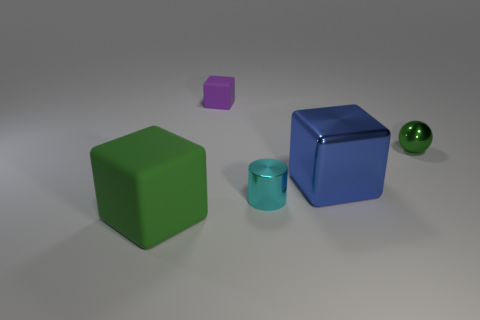What is the size of the block that is the same color as the small shiny ball?
Provide a short and direct response. Large. How many objects are purple rubber blocks that are behind the large blue shiny thing or tiny things in front of the purple thing?
Your answer should be compact. 3. There is a small shiny object that is the same color as the large matte cube; what is its shape?
Offer a very short reply. Sphere. What shape is the green thing on the left side of the tiny purple matte object?
Your answer should be very brief. Cube. Does the small thing on the left side of the cyan cylinder have the same shape as the small green shiny object?
Your answer should be compact. No. What number of things are green things that are behind the cyan object or big green matte objects?
Offer a terse response. 2. The small thing that is the same shape as the big green matte object is what color?
Your answer should be very brief. Purple. Is there anything else of the same color as the big metallic object?
Offer a very short reply. No. How big is the green object behind the small cyan metallic thing?
Offer a very short reply. Small. There is a small metallic cylinder; does it have the same color as the object that is behind the metallic sphere?
Provide a succinct answer. No. 